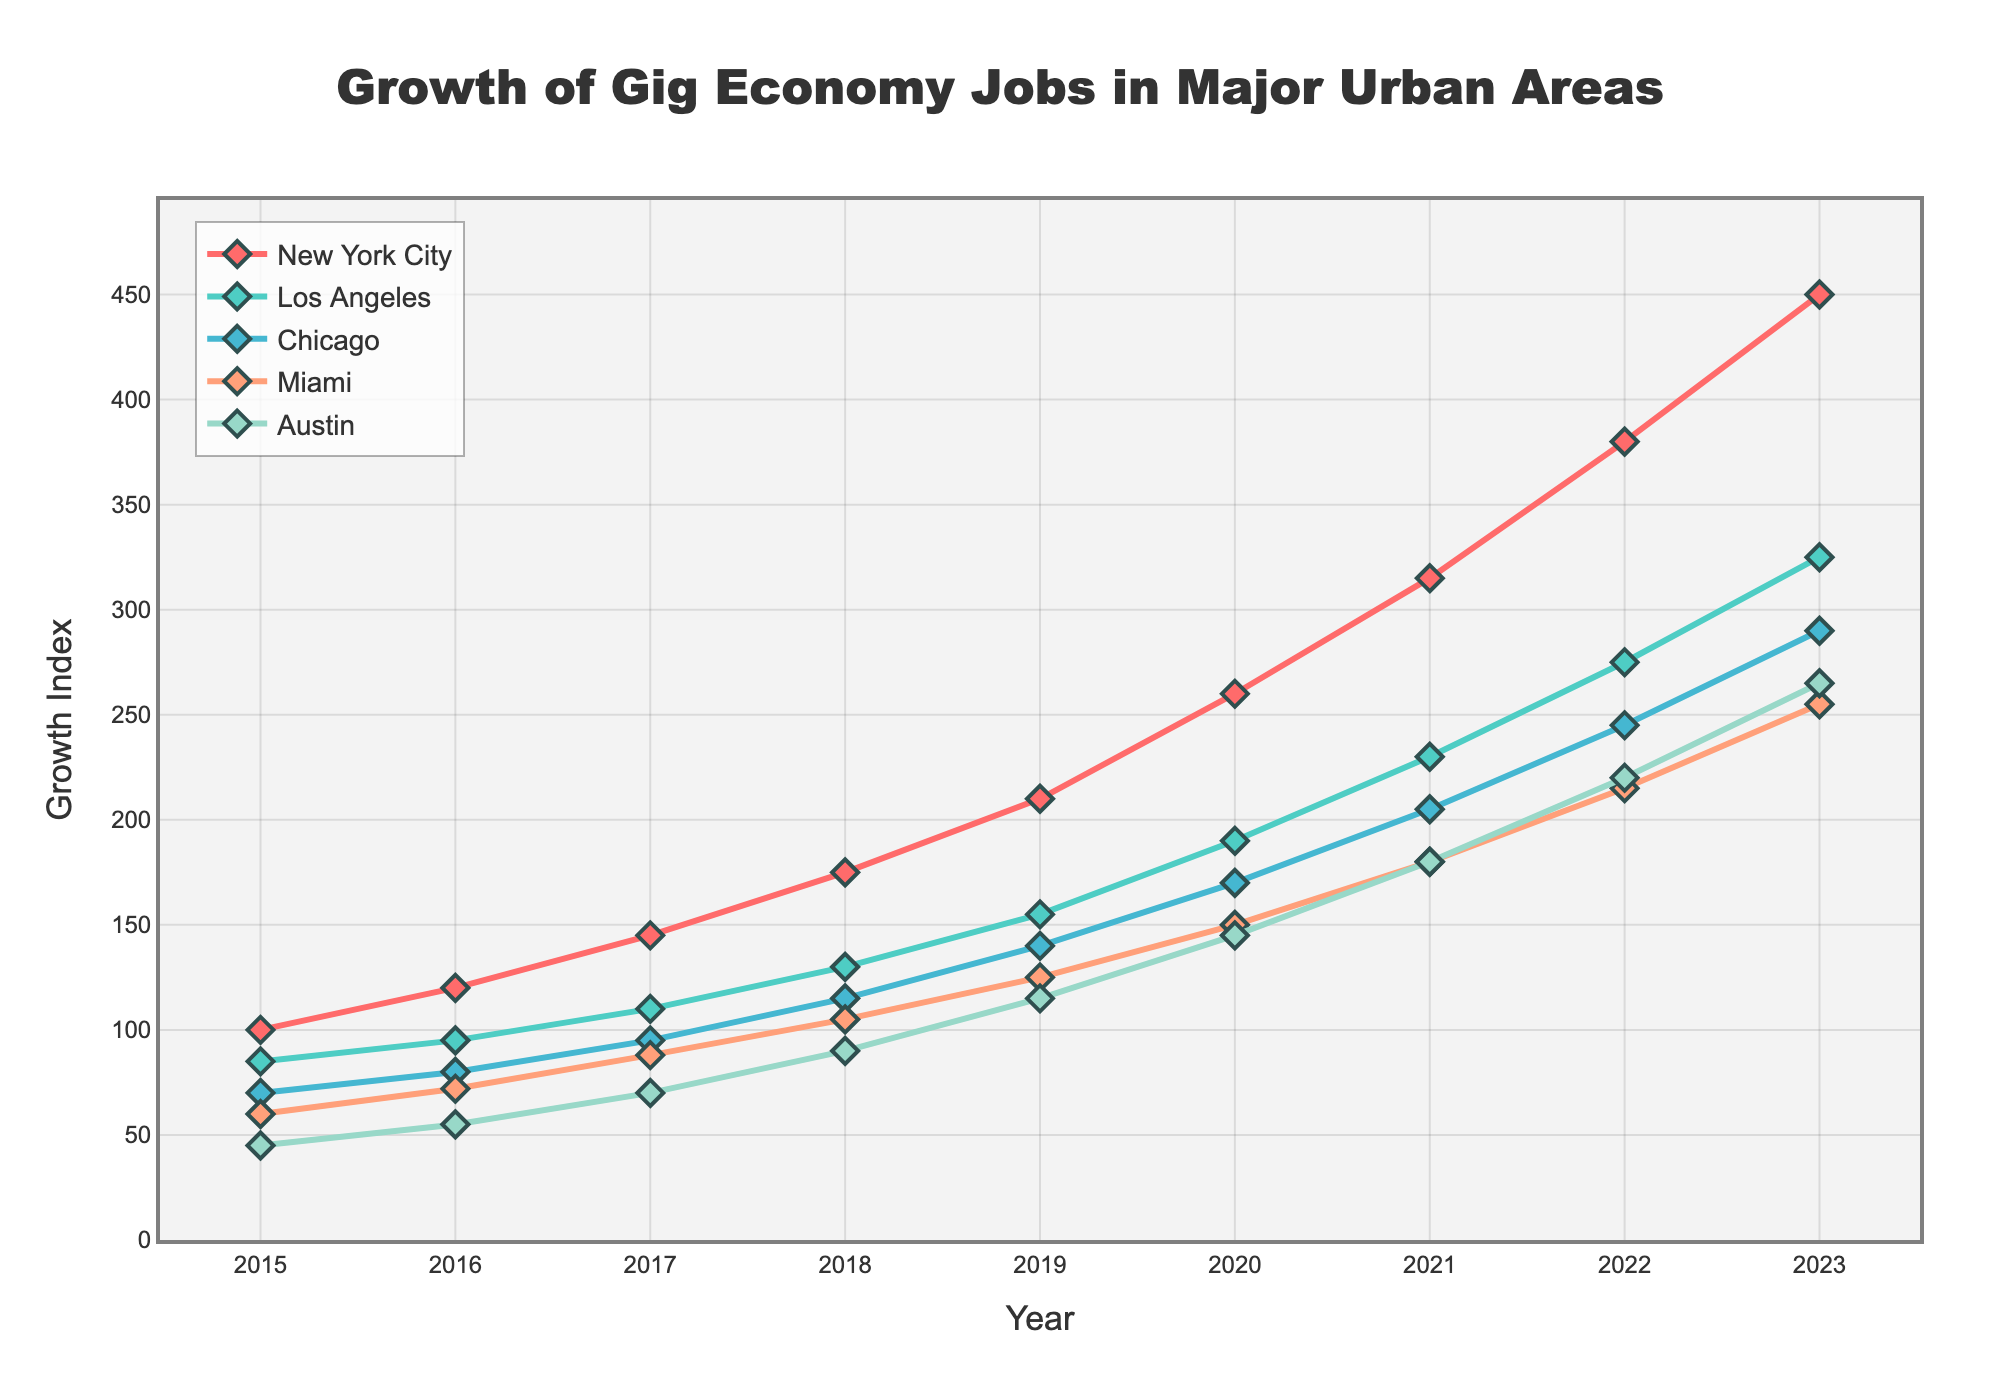What's the overall trend for gig economy jobs in New York City from 2015 to 2023? The figure shows a consistent, upward trend for New York City. Starting at a base value of 100 in 2015 and reaching 450 by 2023, the growth index increases every year, indicating a strong rise in gig economy jobs.
Answer: Consistent upward trend Between which years did Austin see the largest increase in gig economy jobs? The largest increase in Austin’s gig economy jobs is observed between 2021 and 2022. Here, the growth index increased from 180 to 220, which is a 40-point increase.
Answer: 2021 to 2022 How does the growth in Miami compare to that in Chicago by 2023? By 2023, Miami has a growth index of 255 while Chicago has 290. Therefore, the gig economy in Chicago has grown more than in Miami.
Answer: Chicago > Miami What’s the sum of the growth indices for 2023 in New York City and Los Angeles? In 2023, New York City has a growth index of 450 and Los Angeles has 325. Adding these values together gives 450 + 325 = 775.
Answer: 775 Which city experienced the fastest rate of growth overall from 2015 to 2023? New York City started from 100 in 2015 and grew to 450 in 2023, representing the highest increase (by 350 points) compared to other cities.
Answer: New York City By how much did Chicago’s growth index increase from 2016 to 2017? In 2016, Chicago had a growth index of 80, and by 2017 it increased to 95. The difference is 95 - 80, which is a 15-point increase.
Answer: 15 points Which city had the smallest growth index in 2020 and what was it? In 2020, Austin had the smallest growth index of 145 among the cities listed.
Answer: Austin, 145 How does the color coding help distinguish the cities in the figure? Different colors are used for each city's line and markers, which makes it easier to visually separate and identify each city’s growth trend in the figure.
Answer: Helps distinguish cities visually What is the average growth index for Los Angeles from 2015 to 2023? Los Angeles has growth indices: 85, 95, 110, 130, 155, 190, 230, 275, 325. The sum is 1595. Dividing by 9 years, the average is approximately 177.2.
Answer: 177.2 Compare the growth of gig economy jobs in New York City and Austin in terms of visual representation by 2023. New York City's line is the highest on the chart with a sharper upward trend, indicating much higher job growth than Austin's more moderate rise, which is lower and has smoother increments.
Answer: New York City > Austin 